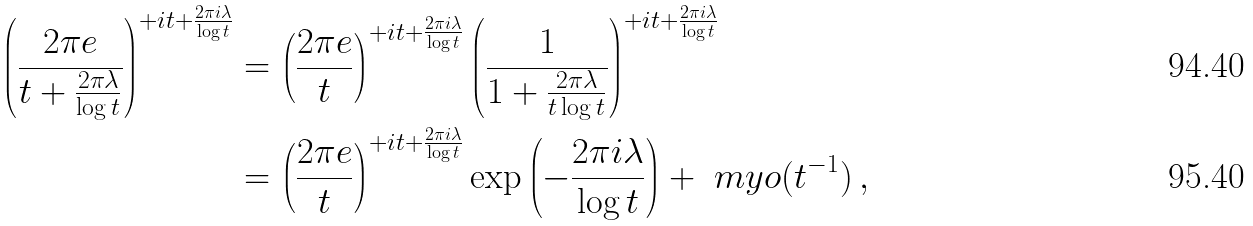Convert formula to latex. <formula><loc_0><loc_0><loc_500><loc_500>\left ( \frac { 2 \pi e } { t + \frac { 2 \pi \lambda } { \log t } } \right ) ^ { + i t + \frac { 2 \pi i \lambda } { \log t } } & = \left ( \frac { 2 \pi e } { t } \right ) ^ { + i t + \frac { 2 \pi i \lambda } { \log t } } \left ( \frac { 1 } { 1 + \frac { 2 \pi \lambda } { t \log t } } \right ) ^ { + i t + \frac { 2 \pi i \lambda } { \log t } } \\ & = \left ( \frac { 2 \pi e } { t } \right ) ^ { + i t + \frac { 2 \pi i \lambda } { \log t } } \exp \left ( - \frac { 2 \pi i \lambda } { \log t } \right ) + \ m y o ( t ^ { - 1 } ) \, ,</formula> 